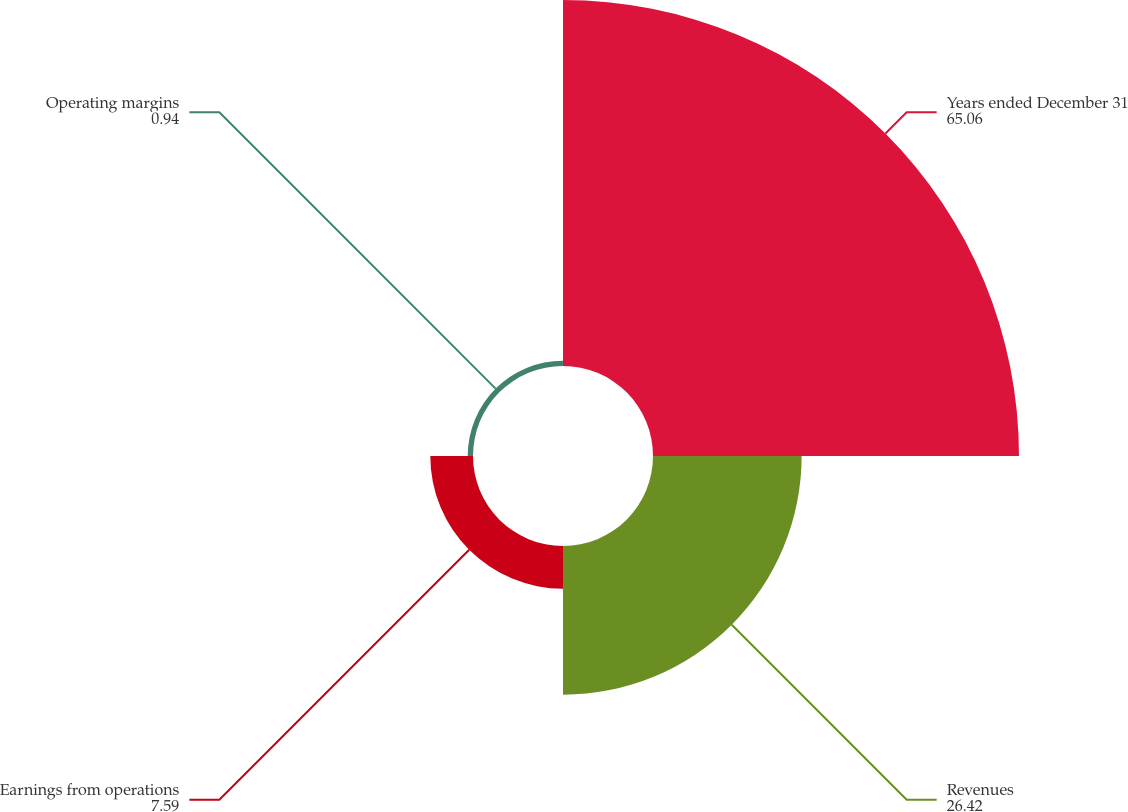Convert chart to OTSL. <chart><loc_0><loc_0><loc_500><loc_500><pie_chart><fcel>Years ended December 31<fcel>Revenues<fcel>Earnings from operations<fcel>Operating margins<nl><fcel>65.06%<fcel>26.42%<fcel>7.59%<fcel>0.94%<nl></chart> 